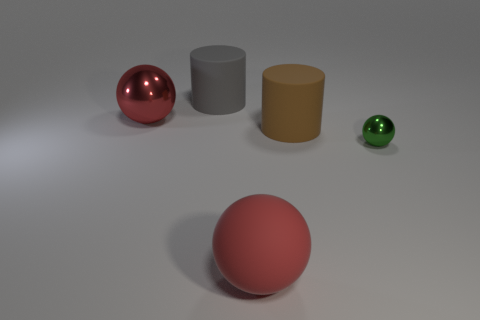Subtract all small green spheres. How many spheres are left? 2 Subtract all cyan cylinders. How many red spheres are left? 2 Subtract all green spheres. How many spheres are left? 2 Add 4 brown metal cubes. How many objects exist? 9 Subtract all spheres. How many objects are left? 2 Subtract all gray balls. Subtract all brown blocks. How many balls are left? 3 Add 3 red objects. How many red objects exist? 5 Subtract 0 cyan spheres. How many objects are left? 5 Subtract all red cubes. Subtract all red shiny things. How many objects are left? 4 Add 2 green balls. How many green balls are left? 3 